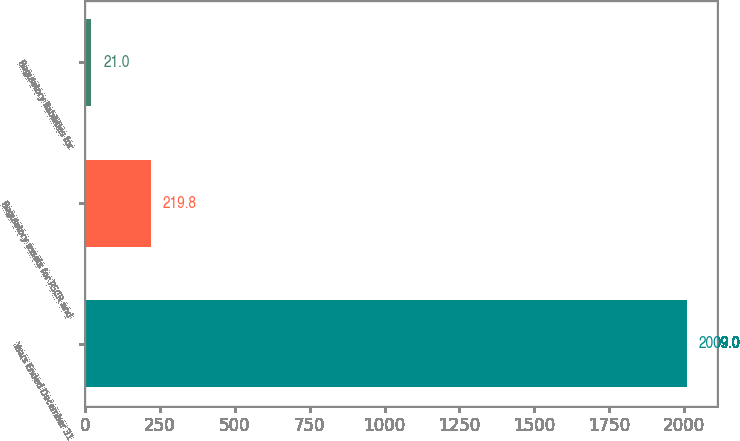<chart> <loc_0><loc_0><loc_500><loc_500><bar_chart><fcel>Years Ended December 31<fcel>Regulatory assets for PSCR and<fcel>Regulatory liabilities for<nl><fcel>2009<fcel>219.8<fcel>21<nl></chart> 